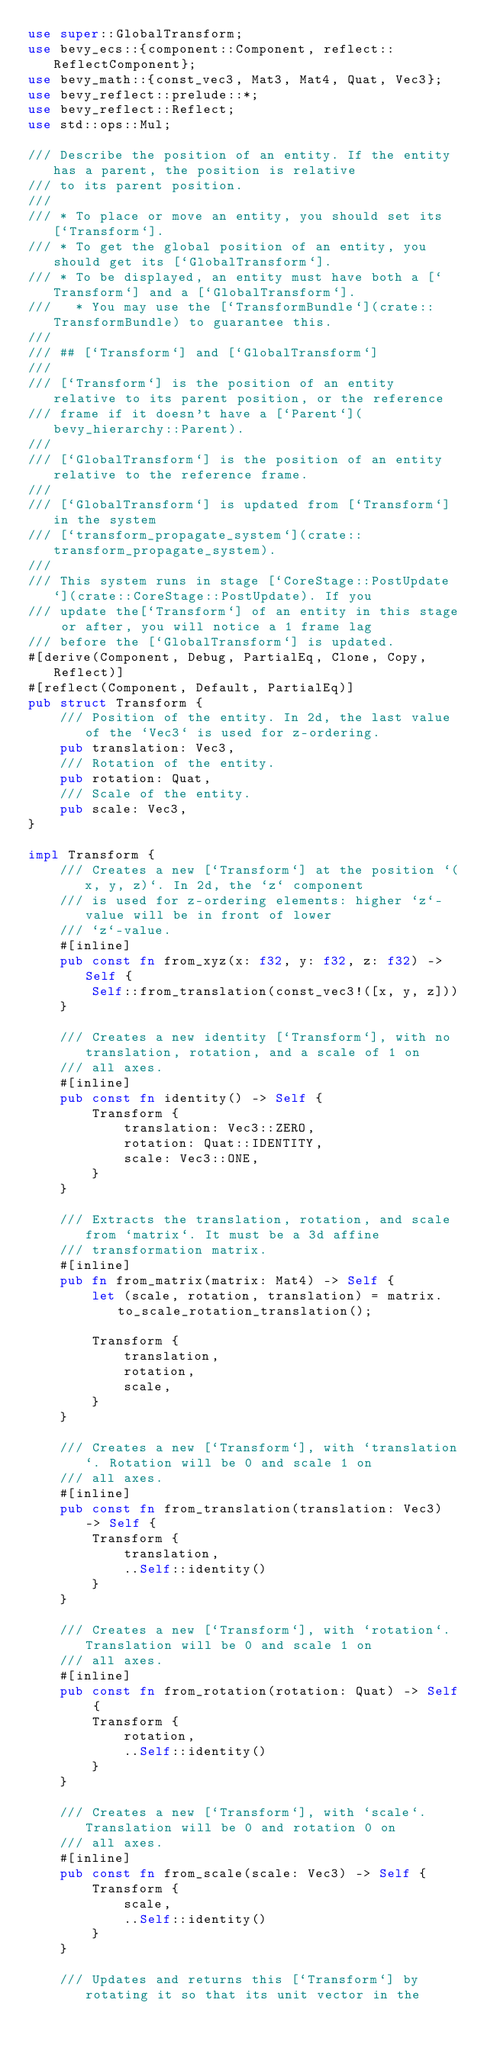<code> <loc_0><loc_0><loc_500><loc_500><_Rust_>use super::GlobalTransform;
use bevy_ecs::{component::Component, reflect::ReflectComponent};
use bevy_math::{const_vec3, Mat3, Mat4, Quat, Vec3};
use bevy_reflect::prelude::*;
use bevy_reflect::Reflect;
use std::ops::Mul;

/// Describe the position of an entity. If the entity has a parent, the position is relative
/// to its parent position.
///
/// * To place or move an entity, you should set its [`Transform`].
/// * To get the global position of an entity, you should get its [`GlobalTransform`].
/// * To be displayed, an entity must have both a [`Transform`] and a [`GlobalTransform`].
///   * You may use the [`TransformBundle`](crate::TransformBundle) to guarantee this.
///
/// ## [`Transform`] and [`GlobalTransform`]
///
/// [`Transform`] is the position of an entity relative to its parent position, or the reference
/// frame if it doesn't have a [`Parent`](bevy_hierarchy::Parent).
///
/// [`GlobalTransform`] is the position of an entity relative to the reference frame.
///
/// [`GlobalTransform`] is updated from [`Transform`] in the system
/// [`transform_propagate_system`](crate::transform_propagate_system).
///
/// This system runs in stage [`CoreStage::PostUpdate`](crate::CoreStage::PostUpdate). If you
/// update the[`Transform`] of an entity in this stage or after, you will notice a 1 frame lag
/// before the [`GlobalTransform`] is updated.
#[derive(Component, Debug, PartialEq, Clone, Copy, Reflect)]
#[reflect(Component, Default, PartialEq)]
pub struct Transform {
    /// Position of the entity. In 2d, the last value of the `Vec3` is used for z-ordering.
    pub translation: Vec3,
    /// Rotation of the entity.
    pub rotation: Quat,
    /// Scale of the entity.
    pub scale: Vec3,
}

impl Transform {
    /// Creates a new [`Transform`] at the position `(x, y, z)`. In 2d, the `z` component
    /// is used for z-ordering elements: higher `z`-value will be in front of lower
    /// `z`-value.
    #[inline]
    pub const fn from_xyz(x: f32, y: f32, z: f32) -> Self {
        Self::from_translation(const_vec3!([x, y, z]))
    }

    /// Creates a new identity [`Transform`], with no translation, rotation, and a scale of 1 on
    /// all axes.
    #[inline]
    pub const fn identity() -> Self {
        Transform {
            translation: Vec3::ZERO,
            rotation: Quat::IDENTITY,
            scale: Vec3::ONE,
        }
    }

    /// Extracts the translation, rotation, and scale from `matrix`. It must be a 3d affine
    /// transformation matrix.
    #[inline]
    pub fn from_matrix(matrix: Mat4) -> Self {
        let (scale, rotation, translation) = matrix.to_scale_rotation_translation();

        Transform {
            translation,
            rotation,
            scale,
        }
    }

    /// Creates a new [`Transform`], with `translation`. Rotation will be 0 and scale 1 on
    /// all axes.
    #[inline]
    pub const fn from_translation(translation: Vec3) -> Self {
        Transform {
            translation,
            ..Self::identity()
        }
    }

    /// Creates a new [`Transform`], with `rotation`. Translation will be 0 and scale 1 on
    /// all axes.
    #[inline]
    pub const fn from_rotation(rotation: Quat) -> Self {
        Transform {
            rotation,
            ..Self::identity()
        }
    }

    /// Creates a new [`Transform`], with `scale`. Translation will be 0 and rotation 0 on
    /// all axes.
    #[inline]
    pub const fn from_scale(scale: Vec3) -> Self {
        Transform {
            scale,
            ..Self::identity()
        }
    }

    /// Updates and returns this [`Transform`] by rotating it so that its unit vector in the</code> 